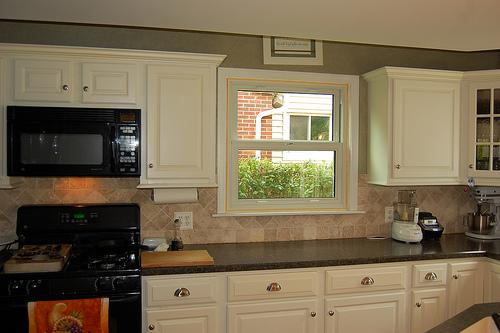Question: what room is depicted in the photo?
Choices:
A. Bedroom.
B. Bathroom.
C. Dining room.
D. A kitchen.
Answer with the letter. Answer: D Question: where is the electric mixer and stand?
Choices:
A. On the counter in the right hand counter.
B. By the dish washer.
C. By the stope.
D. Against the counter.
Answer with the letter. Answer: A Question: how many drawers are in the kitchen?
Choices:
A. Four.
B. Five.
C. Six.
D. Seven.
Answer with the letter. Answer: A Question: where is the microwave?
Choices:
A. Above the stove.
B. On the counter.
C. Below the cupboard.
D. By the sink.
Answer with the letter. Answer: A 